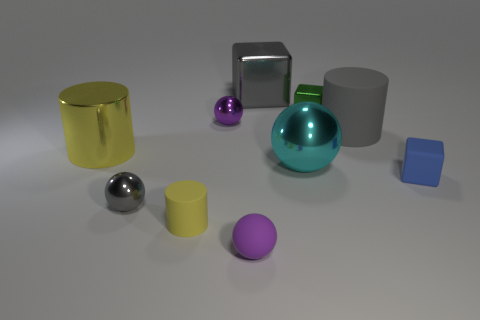What materials do the objects in the image appear to be made from? The objects present varying appearances suggesting different materials. The yellow and gray cylinders look metallic with glossy finishes, while the blue and yellow blocks seem matte, likely plastic. The spheres have reflective surfaces hinting at metallic or glass compositions based on their sheen. 